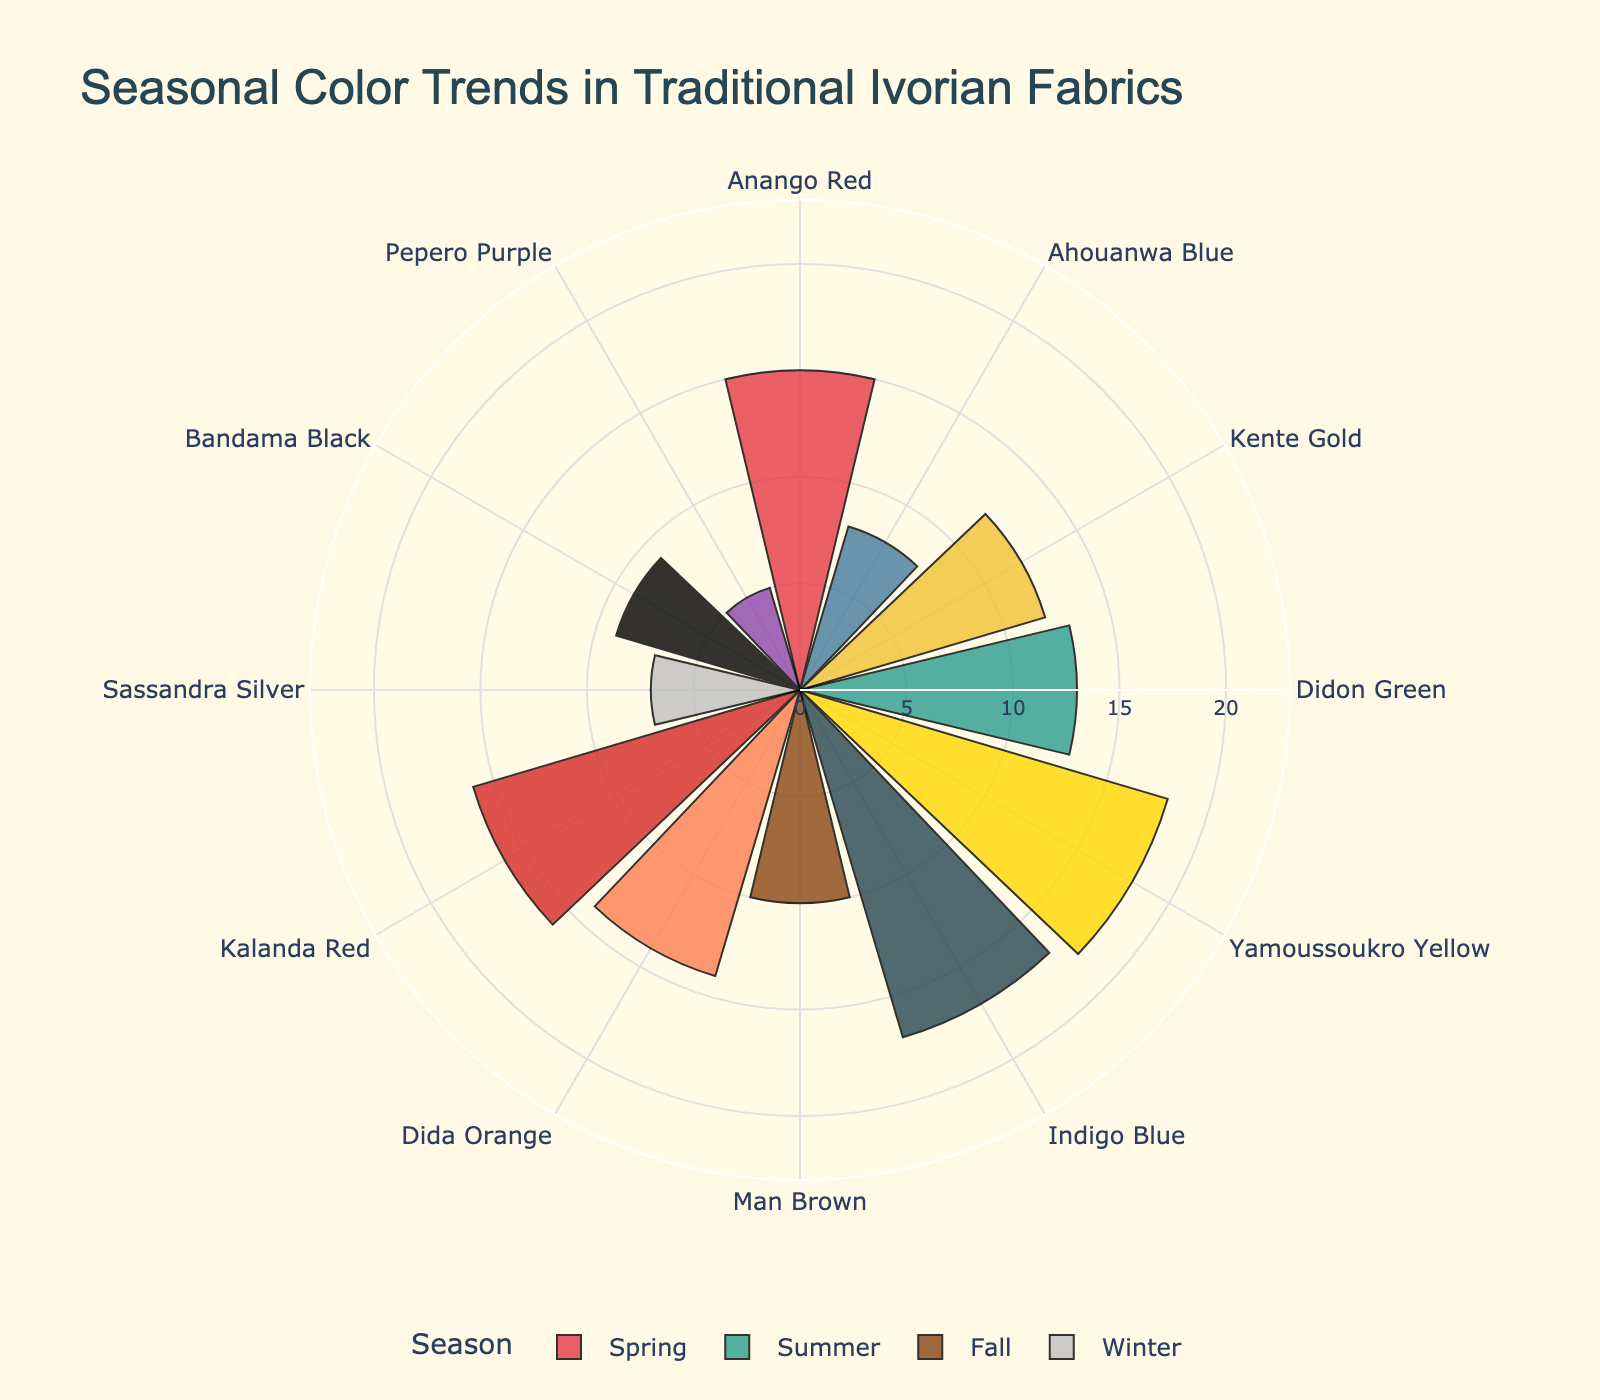What season has the highest number of hue counts for a single color? By looking at the bars on the chart, we can see that the Summer season has the highest hue count for a single color, which is Yamoussoukro Yellow with 18 counts.
Answer: Summer What color is the most popular during Winter? In the Winter segment, we see the popularity indicators (stars). Bandama Black has 9 stars, with 3 stars, making it the most popular in Winter.
Answer: Bandama Black Which season features the color with the lowest hue count? Observing the radial bars, the color Pepero Purple in Winter has the lowest hue count of 5.
Answer: Winter How many colors are represented in the Fall season? By counting the number of bars related to the Fall season segment, we see there are three: Man Brown, Dida Orange, and Kalanda Red.
Answer: 3 Which seasons have an equal number of high popularity colors? By referencing the popularity indicators (stars), both Spring and Fall have two colors each with a 'High' popularity rating (Spring: Anango Red, Kente Gold; Fall: Dida Orange, Kalanda Red).
Answer: Spring and Fall What color in the Summer season has the highest popularity rating? Observing the Summer section, Yamoussoukro Yellow has the 'Very High' rating, indicated by 5 stars.
Answer: Yamoussoukro Yellow Compare the total hue counts of Spring and Fall. Which is greater? Summing the hue counts from Spring: Anango Red (15), Ahouanwa Blue (8), Kente Gold (12) = 35; and Fall: Man Brown (10), Dida Orange (14), Kalanda Red (16) = 40. Fall has a greater total hue count.
Answer: Fall What is the combined popularity rating for the colors in Summer? Converting the popularity ratings to numeric values and summing them: Didon Green (2), Yamoussoukro Yellow (5), Indigo Blue (4), we get 2 + 5 + 4 = 11.
Answer: 11 Which season shows the most diverse range of hues (colors)? By counting the distinct colors within each season segment, all seasons have three colors each, indicating the same diversity in terms of the range of hues.
Answer: All seasons How does the hue count of Indigo Blue in Summer compare with that of Man Brown in Fall? Indigo Blue has a hue count of 17, while Man Brown has a hue count of 10. Indigo Blue's hue count is greater.
Answer: Indigo Blue is greater 